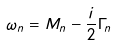<formula> <loc_0><loc_0><loc_500><loc_500>\omega _ { n } = M _ { n } - \frac { i } { 2 } \Gamma _ { n }</formula> 